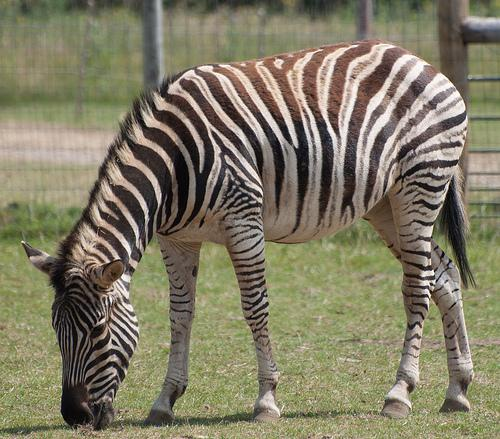Describe the key subject of the image and what is happening. A calm and relaxed zebra is enjoying nourishment from the grass in a protected area within a zoo. Provide a concise summary of the main focus in the image. A zebra is calmly grazing in the grass in a fenced enclosure at a zoo on a sunny day. Concisely describe the primary subject in the image and its setting. A black and white striped zebra eats grass in a fenced, open area with green grass and dirt ground. Capture the key aspects of the image in a single phrase. Zebra serenely grazing within a fenced, grassy space. Explain the main focus of the picture and the current action taking place. A zebra is attentively grazing in a grassy and fenced enclosure while being alert to potential dangers. Create a short statement about the central character in the image and its activity. A young female zebra is peacefully grazing on grass within the boundaries of a sunlit enclosure. Describe the main animal in the picture and its momentary action. The young female zebra with black and white stripes is eating grass while standing on a grassy plot. Create a brief overview of the content of the image. The image features a relaxed zebra grazing on grass during daytime within the boundaries of a fenced area. In one sentence, outline the main elements in the picture. The image presents a zebra consuming grass in a sunlit enclosure under the watchful eye of a metal fence. Give a brief description of the central object in the image and its behavior. A zebra with a short mane is feeding on grass while standing in an enclosed, sunlit field. 